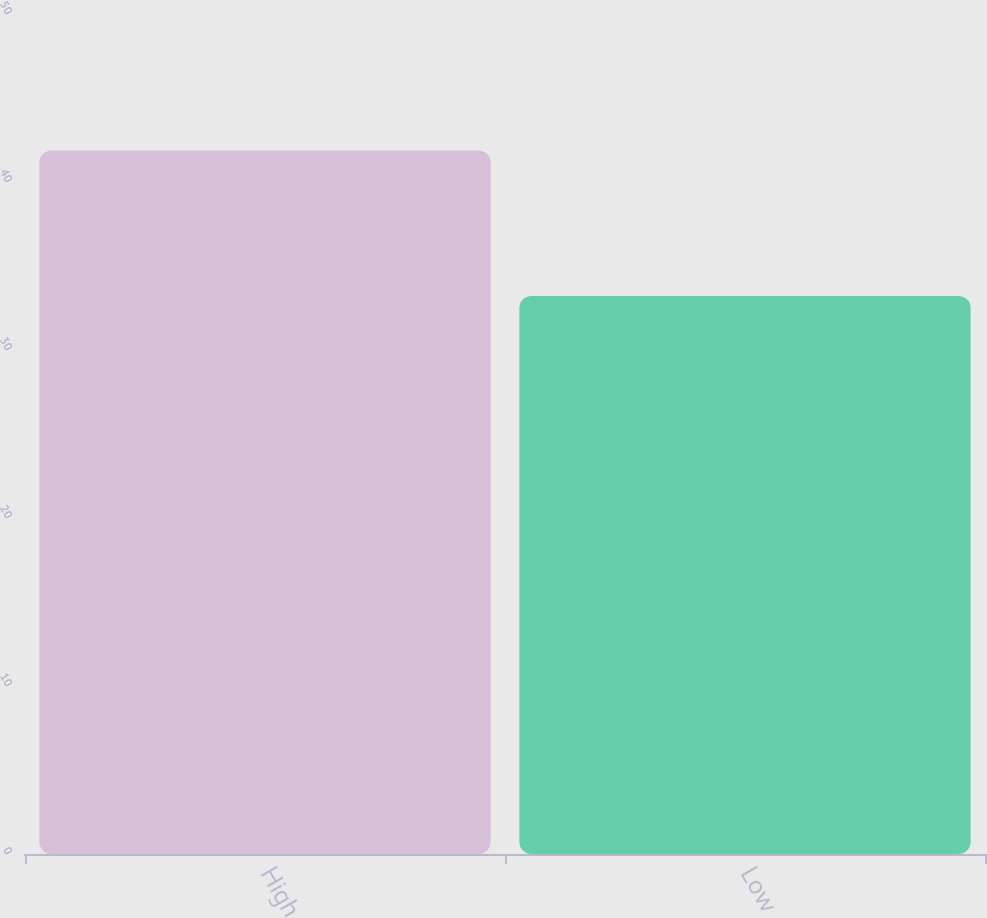<chart> <loc_0><loc_0><loc_500><loc_500><bar_chart><fcel>High<fcel>Low<nl><fcel>41.87<fcel>33.22<nl></chart> 